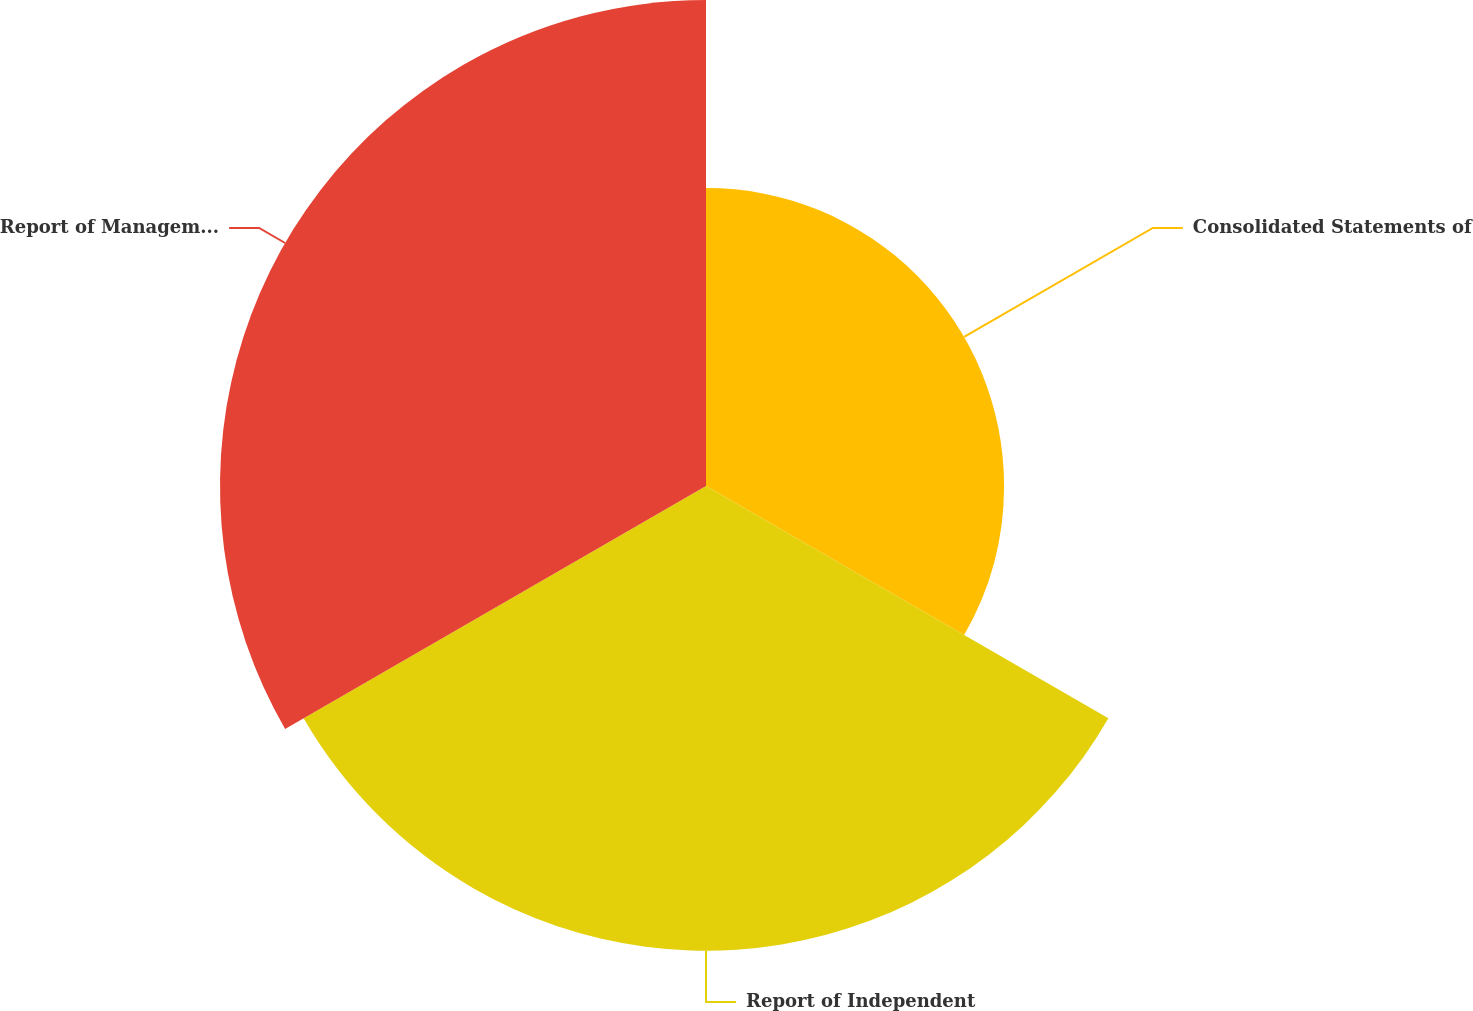Convert chart. <chart><loc_0><loc_0><loc_500><loc_500><pie_chart><fcel>Consolidated Statements of<fcel>Report of Independent<fcel>Report of Management on<nl><fcel>23.87%<fcel>37.21%<fcel>38.92%<nl></chart> 